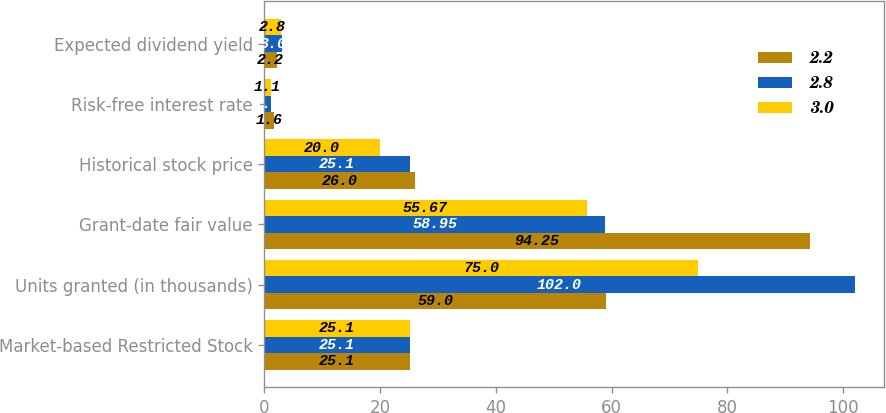<chart> <loc_0><loc_0><loc_500><loc_500><stacked_bar_chart><ecel><fcel>Market-based Restricted Stock<fcel>Units granted (in thousands)<fcel>Grant-date fair value<fcel>Historical stock price<fcel>Risk-free interest rate<fcel>Expected dividend yield<nl><fcel>2.2<fcel>25.1<fcel>59<fcel>94.25<fcel>26<fcel>1.6<fcel>2.2<nl><fcel>2.8<fcel>25.1<fcel>102<fcel>58.95<fcel>25.1<fcel>1.1<fcel>3<nl><fcel>3<fcel>25.1<fcel>75<fcel>55.67<fcel>20<fcel>1.1<fcel>2.8<nl></chart> 